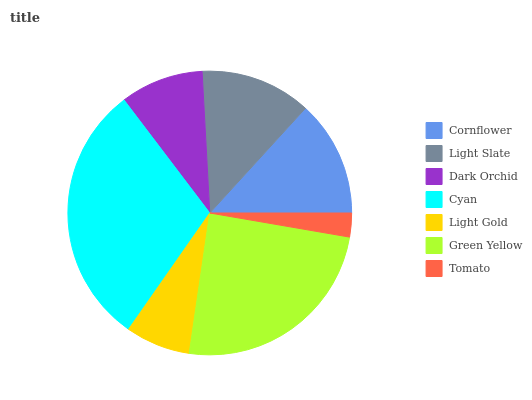Is Tomato the minimum?
Answer yes or no. Yes. Is Cyan the maximum?
Answer yes or no. Yes. Is Light Slate the minimum?
Answer yes or no. No. Is Light Slate the maximum?
Answer yes or no. No. Is Cornflower greater than Light Slate?
Answer yes or no. Yes. Is Light Slate less than Cornflower?
Answer yes or no. Yes. Is Light Slate greater than Cornflower?
Answer yes or no. No. Is Cornflower less than Light Slate?
Answer yes or no. No. Is Light Slate the high median?
Answer yes or no. Yes. Is Light Slate the low median?
Answer yes or no. Yes. Is Dark Orchid the high median?
Answer yes or no. No. Is Tomato the low median?
Answer yes or no. No. 